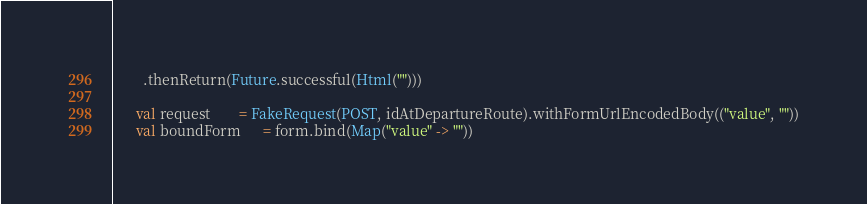<code> <loc_0><loc_0><loc_500><loc_500><_Scala_>        .thenReturn(Future.successful(Html("")))

      val request        = FakeRequest(POST, idAtDepartureRoute).withFormUrlEncodedBody(("value", ""))
      val boundForm      = form.bind(Map("value" -> ""))</code> 